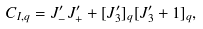Convert formula to latex. <formula><loc_0><loc_0><loc_500><loc_500>C _ { I , q } = J _ { - } ^ { \prime } J _ { + } ^ { \prime } + [ J _ { 3 } ^ { \prime } ] _ { q } [ J _ { 3 } ^ { \prime } + 1 ] _ { q } ,</formula> 